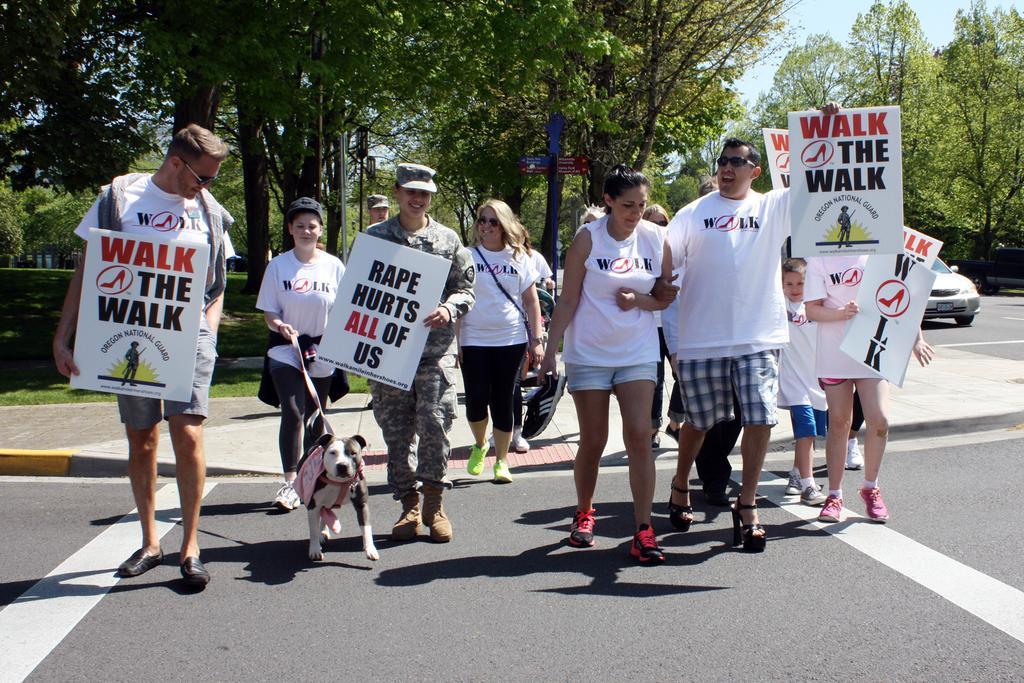In one or two sentences, can you explain what this image depicts? Few people are walking on the roads with placards and behind them there are trees. 